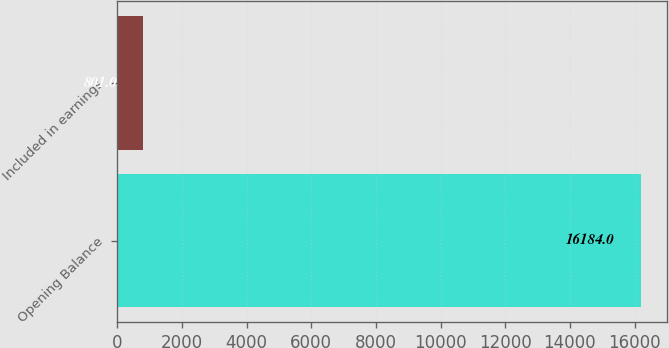<chart> <loc_0><loc_0><loc_500><loc_500><bar_chart><fcel>Opening Balance<fcel>Included in earnings<nl><fcel>16184<fcel>801<nl></chart> 